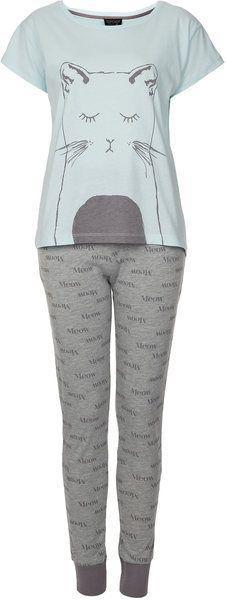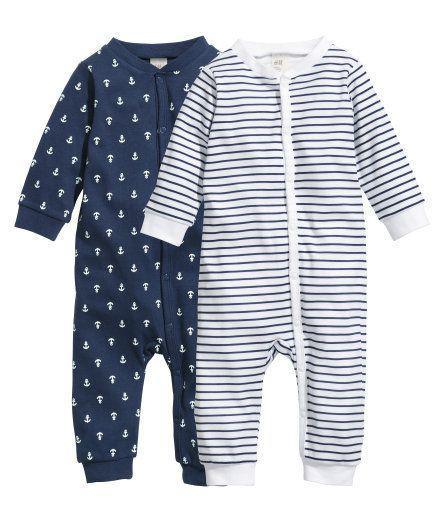The first image is the image on the left, the second image is the image on the right. For the images displayed, is the sentence "There is one outfit containing two articles of clothing per image." factually correct? Answer yes or no. No. The first image is the image on the left, the second image is the image on the right. Given the left and right images, does the statement "At least one of the outfits features an animal-themed design." hold true? Answer yes or no. Yes. 